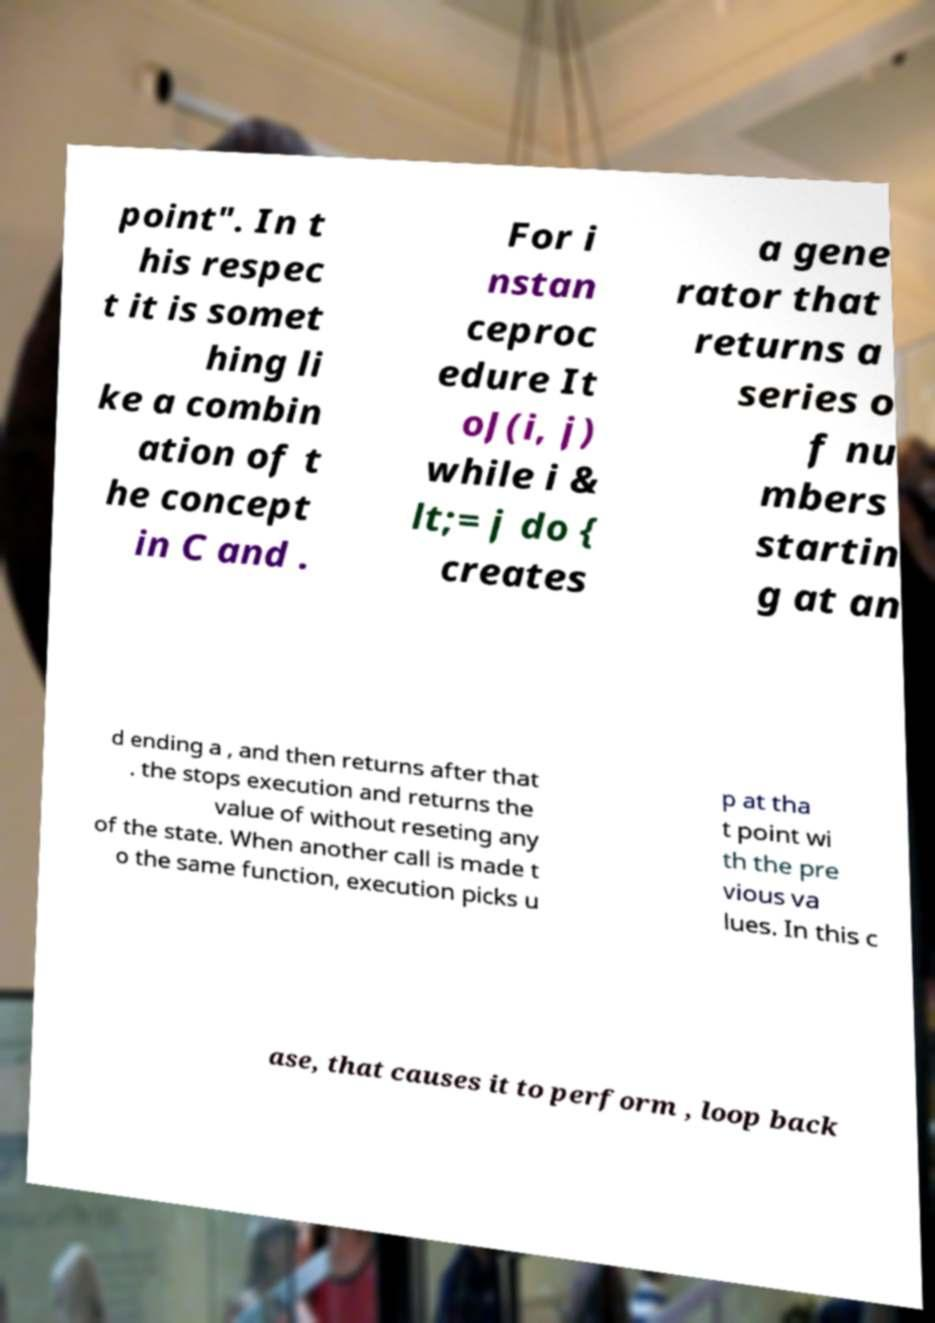What messages or text are displayed in this image? I need them in a readable, typed format. point". In t his respec t it is somet hing li ke a combin ation of t he concept in C and . For i nstan ceproc edure It oJ(i, j) while i & lt;= j do { creates a gene rator that returns a series o f nu mbers startin g at an d ending a , and then returns after that . the stops execution and returns the value of without reseting any of the state. When another call is made t o the same function, execution picks u p at tha t point wi th the pre vious va lues. In this c ase, that causes it to perform , loop back 